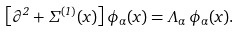Convert formula to latex. <formula><loc_0><loc_0><loc_500><loc_500>\left [ \partial ^ { 2 } + \Sigma ^ { ( 1 ) } ( x ) \right ] \phi _ { \alpha } ( x ) = \Lambda _ { \alpha } \, \phi _ { \alpha } ( x ) .</formula> 